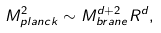<formula> <loc_0><loc_0><loc_500><loc_500>M ^ { 2 } _ { p l a n c k } \sim M ^ { d + 2 } _ { b r a n e } R ^ { d } ,</formula> 